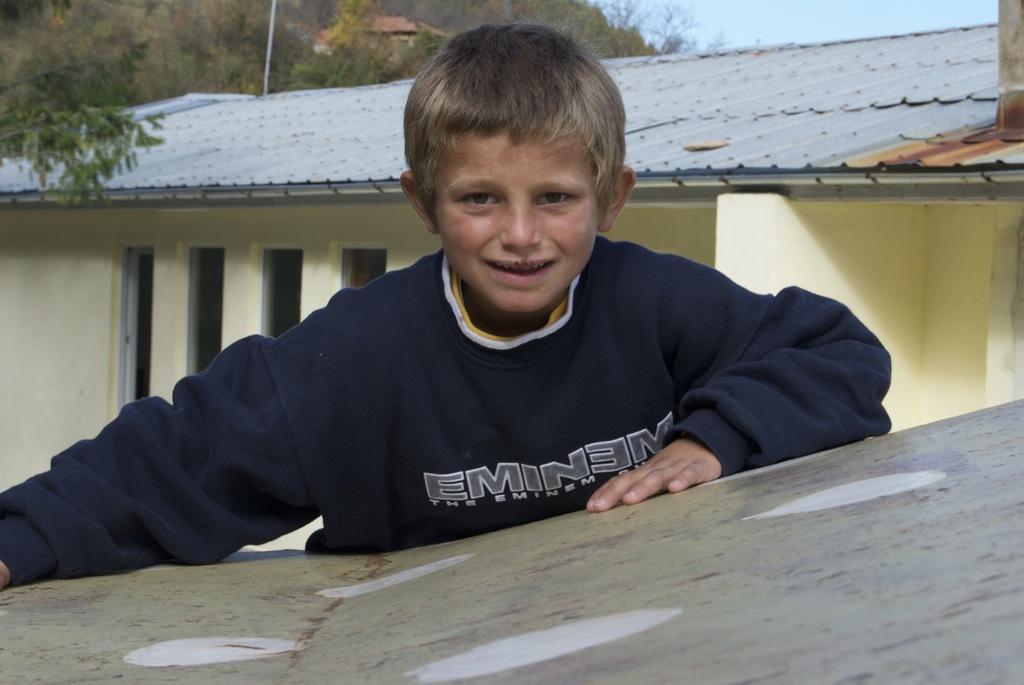Describe this image in one or two sentences. In this picture there is a kid wearing blue dress placed his hands on an object and there is a house behind him and there are trees in the background. 